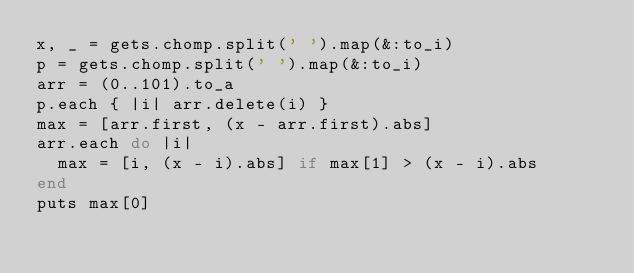<code> <loc_0><loc_0><loc_500><loc_500><_Ruby_>x, _ = gets.chomp.split(' ').map(&:to_i)
p = gets.chomp.split(' ').map(&:to_i)
arr = (0..101).to_a
p.each { |i| arr.delete(i) }
max = [arr.first, (x - arr.first).abs]
arr.each do |i|
  max = [i, (x - i).abs] if max[1] > (x - i).abs
end
puts max[0]</code> 